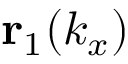Convert formula to latex. <formula><loc_0><loc_0><loc_500><loc_500>r _ { 1 } ( k _ { x } )</formula> 